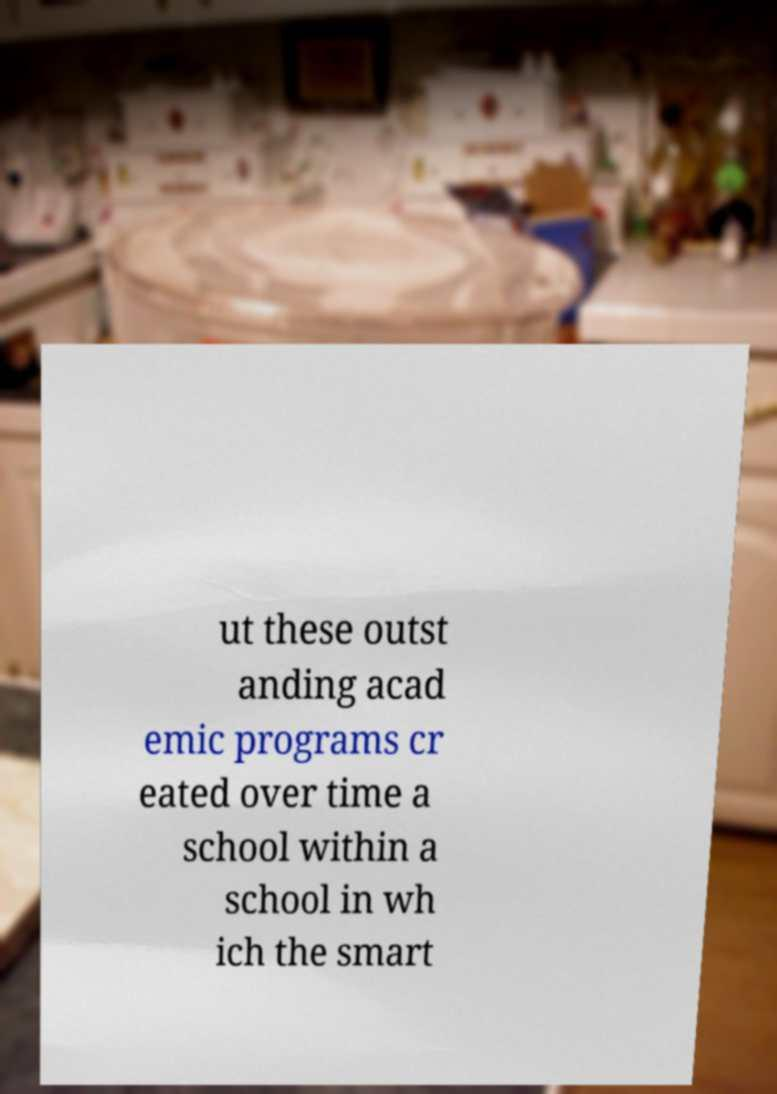For documentation purposes, I need the text within this image transcribed. Could you provide that? ut these outst anding acad emic programs cr eated over time a school within a school in wh ich the smart 